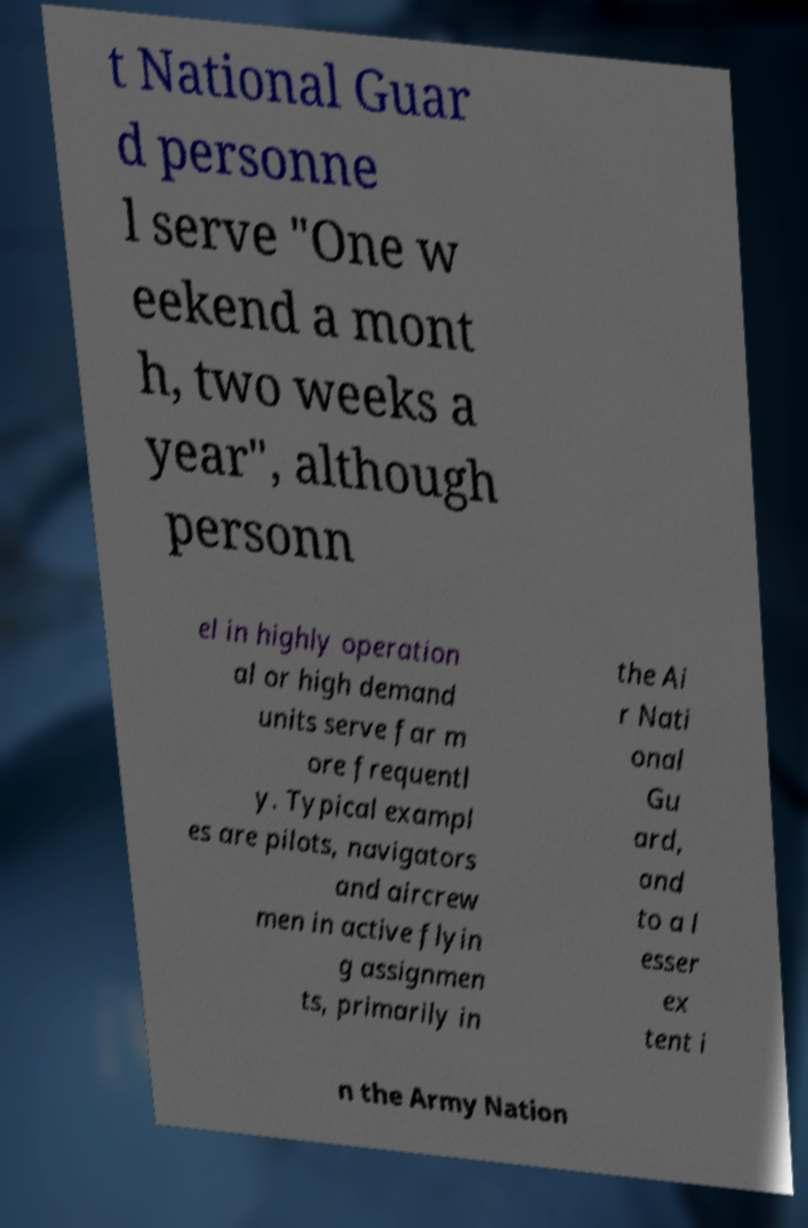I need the written content from this picture converted into text. Can you do that? t National Guar d personne l serve "One w eekend a mont h, two weeks a year", although personn el in highly operation al or high demand units serve far m ore frequentl y. Typical exampl es are pilots, navigators and aircrew men in active flyin g assignmen ts, primarily in the Ai r Nati onal Gu ard, and to a l esser ex tent i n the Army Nation 